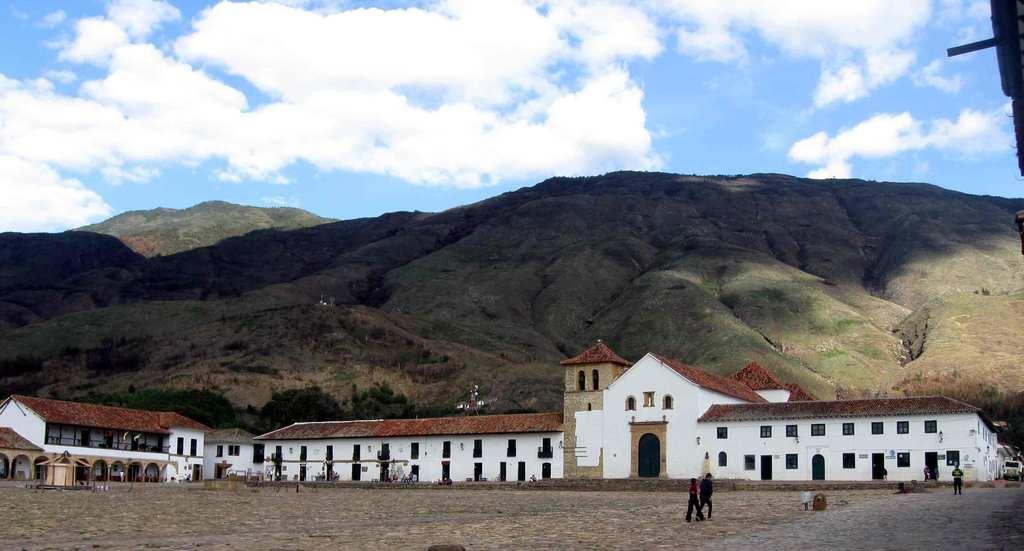Can you describe this image briefly? In this picture we can see the buildings and hills. In front of the buildings, there are people, a road and some objects. On the right side of the image, it looks like a vehicle. At the top of the image, there is the sky. 